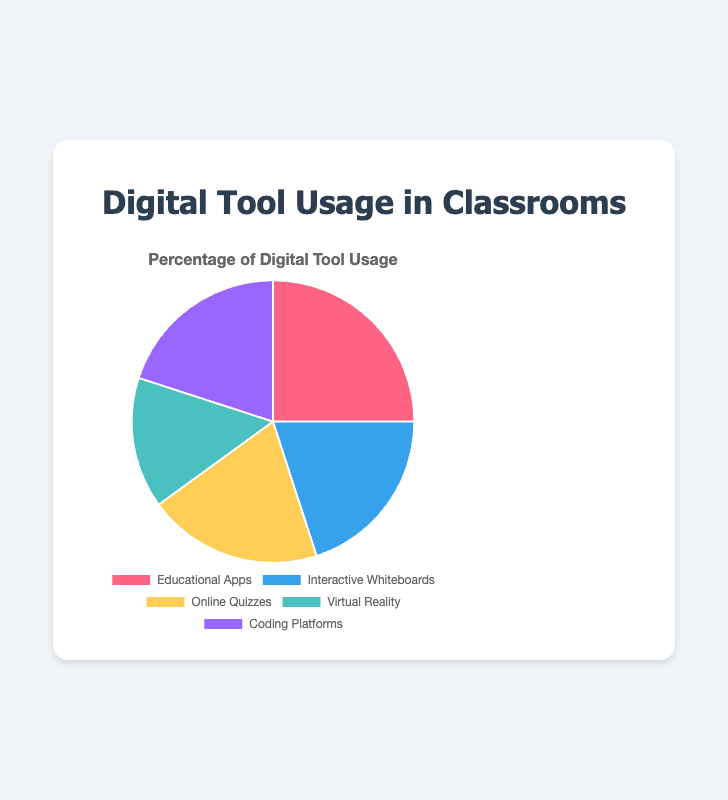Which digital tool has the highest usage percentage? The pie chart shows the usage percentage of different digital tools in classrooms. The segment with the highest percentage is "Educational Apps" at 25%.
Answer: Educational Apps Which digital tools have equal usage percentages? The pie chart displays the usage percentages of various digital tools. "Interactive Whiteboards", "Online Quizzes", and "Coding Platforms" each have a usage percentage of 20%.
Answer: Interactive Whiteboards, Online Quizzes, Coding Platforms What is the total usage percentage of "Virtual Reality" and "Educational Apps"? To find the total usage percentage of both tools, sum the usage percentages of "Virtual Reality" (15%) and "Educational Apps" (25%): 15% + 25% = 40%.
Answer: 40% Which tool has the lowest usage percentage, and what is it? The pie chart illustrates the usage percentages. "Virtual Reality" has the smallest segment, indicating its usage percentage is the lowest at 15%.
Answer: Virtual Reality (15%) How does the usage percentage of "Coding Platforms" compare to "Virtual Reality"? The pie chart shows that "Coding Platforms" has a usage percentage of 20%, while "Virtual Reality" has 15%. Therefore, "Coding Platforms" has a higher usage percentage by 5%.
Answer: Coding Platforms have 5% more than Virtual Reality Combine the percentages of "Online Quizzes" and "Interactive Whiteboards", then compare it to that of "Educational Apps". Which is greater? First, add the usage percentages of "Online Quizzes" (20%) and "Interactive Whiteboards" (20%): 20% + 20% = 40%. "Educational Apps" has a usage percentage of 25%. Therefore, the combined percentage (40%) is greater than that of "Educational Apps" (25%).
Answer: Combined percentage (40%) is greater What percentage of the total classroom usage is attributed to tools other than "Educational Apps"? Calculate the total usage percentage of tools other than "Educational Apps" by summing the percentages: 20% (Interactive Whiteboards) + 20% (Online Quizzes) + 15% (Virtual Reality) + 20% (Coding Platforms) = 75%. Thus, other tools make up 75% of the total usage.
Answer: 75% 